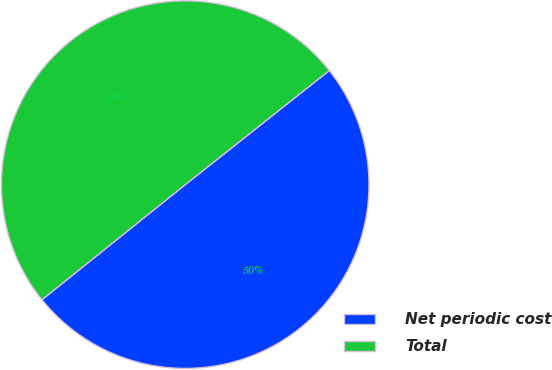Convert chart. <chart><loc_0><loc_0><loc_500><loc_500><pie_chart><fcel>Net periodic cost<fcel>Total<nl><fcel>49.9%<fcel>50.1%<nl></chart> 